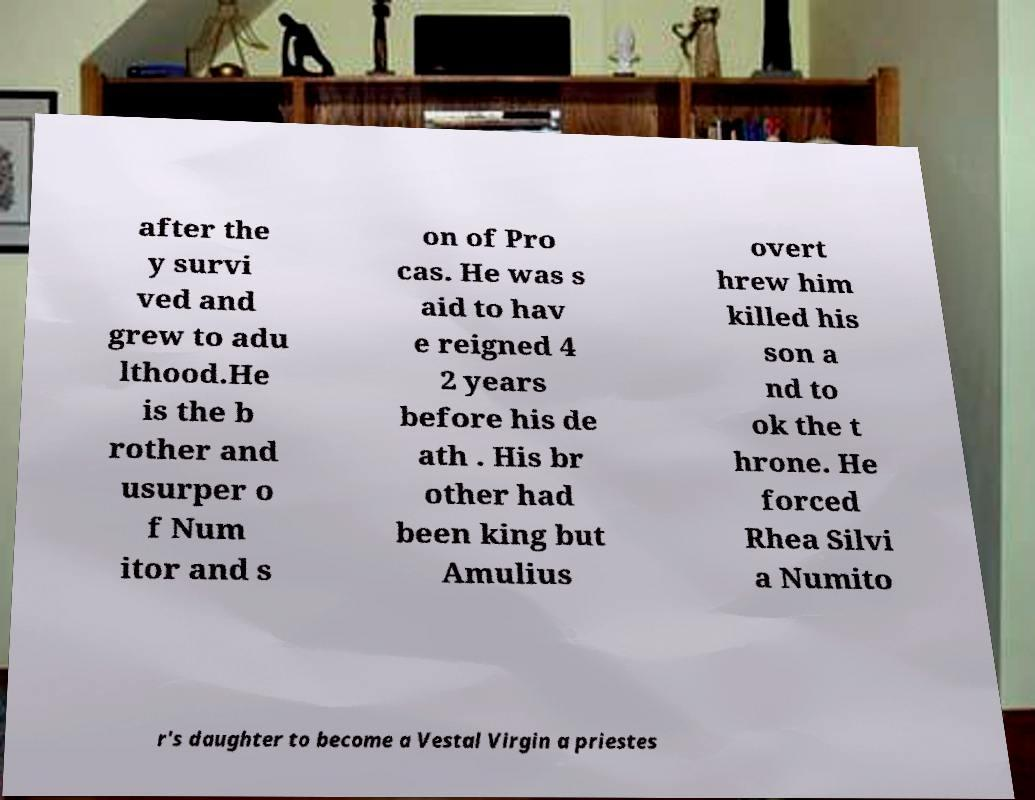Can you accurately transcribe the text from the provided image for me? after the y survi ved and grew to adu lthood.He is the b rother and usurper o f Num itor and s on of Pro cas. He was s aid to hav e reigned 4 2 years before his de ath . His br other had been king but Amulius overt hrew him killed his son a nd to ok the t hrone. He forced Rhea Silvi a Numito r's daughter to become a Vestal Virgin a priestes 